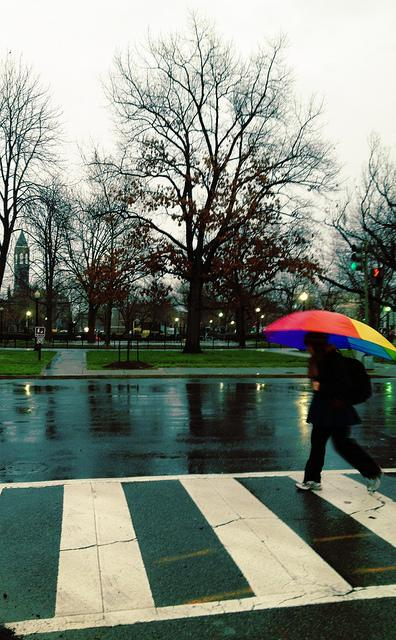What is the person with the umbrella walking on? crosswalk 